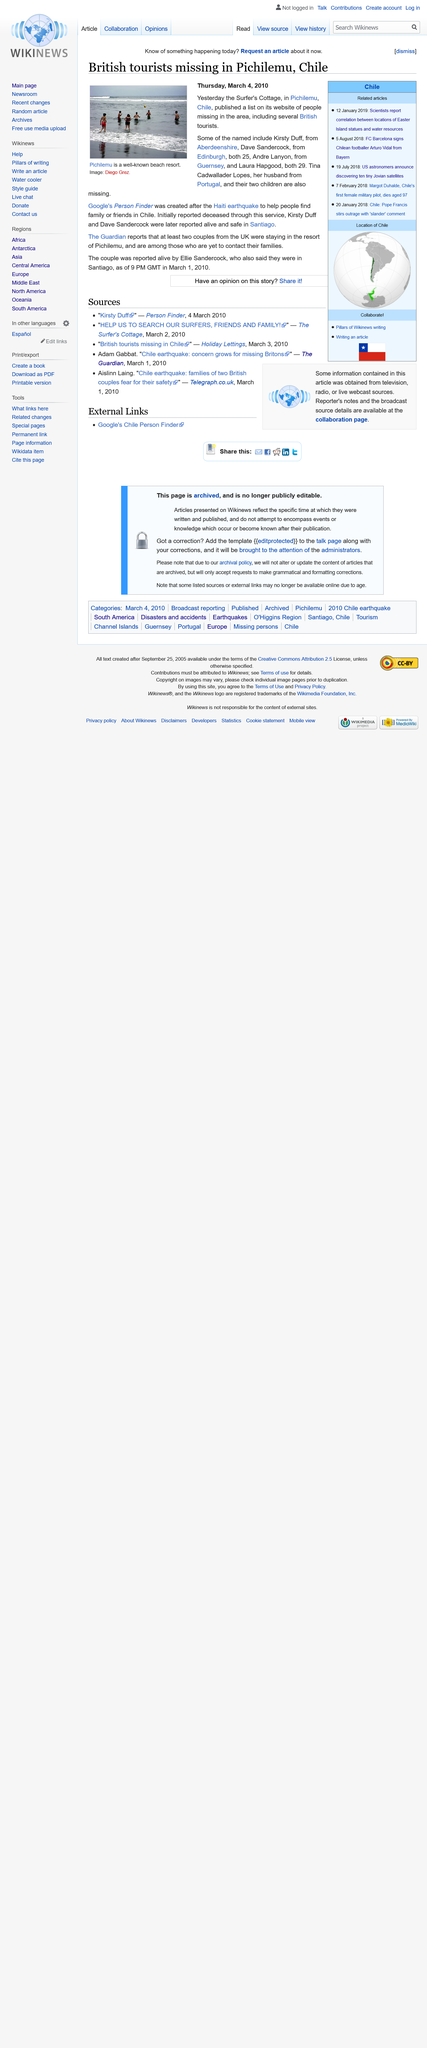Point out several critical features in this image. Google's Person Finder was developed in response to the Haiti earthquake to assist individuals in locating their loved ones during a natural disaster. It has since been utilized in various other disaster relief efforts, including the Chilean earthquake. The image depicts the renowned beach destination of Pichilemu, which is widely recognized for its stunning coastal landscapes and vibrant coastal culture. At least two UK couples were reported by The Guardian to be staying in the resort. 